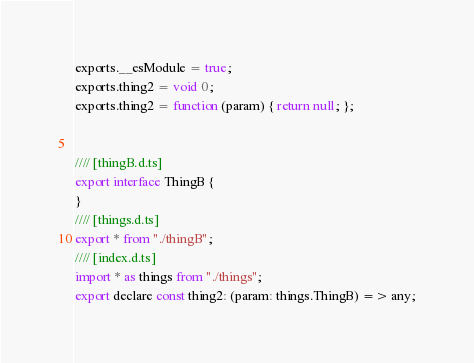<code> <loc_0><loc_0><loc_500><loc_500><_JavaScript_>exports.__esModule = true;
exports.thing2 = void 0;
exports.thing2 = function (param) { return null; };


//// [thingB.d.ts]
export interface ThingB {
}
//// [things.d.ts]
export * from "./thingB";
//// [index.d.ts]
import * as things from "./things";
export declare const thing2: (param: things.ThingB) => any;
</code> 